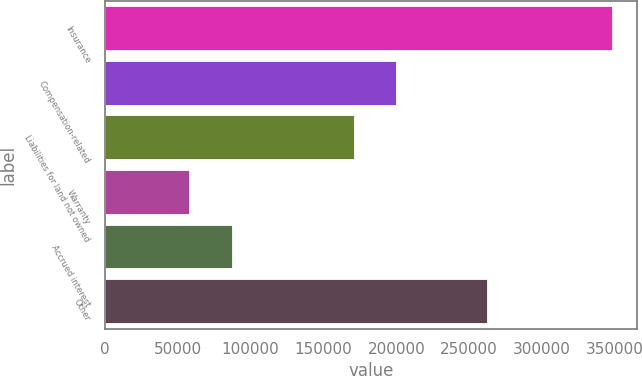Convert chart. <chart><loc_0><loc_0><loc_500><loc_500><bar_chart><fcel>Insurance<fcel>Compensation-related<fcel>Liabilities for land not owned<fcel>Warranty<fcel>Accrued interest<fcel>Other<nl><fcel>347631<fcel>200046<fcel>171101<fcel>58178<fcel>87123.3<fcel>261883<nl></chart> 